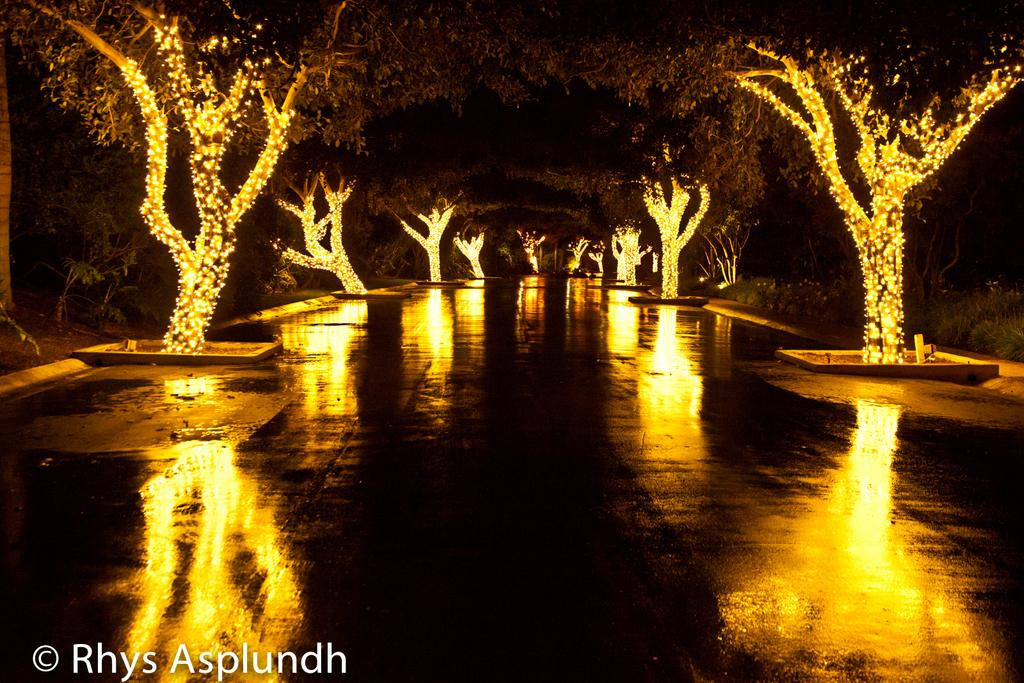What is located on either side of the road in the image? There are trees on either side of the road in the image. How are the trees in the image illuminated? The trees are lighted up. What type of chalk is being used to draw on the bedroom wall in the image? There is no chalk or bedroom wall present in the image; it features trees on either side of a road. 